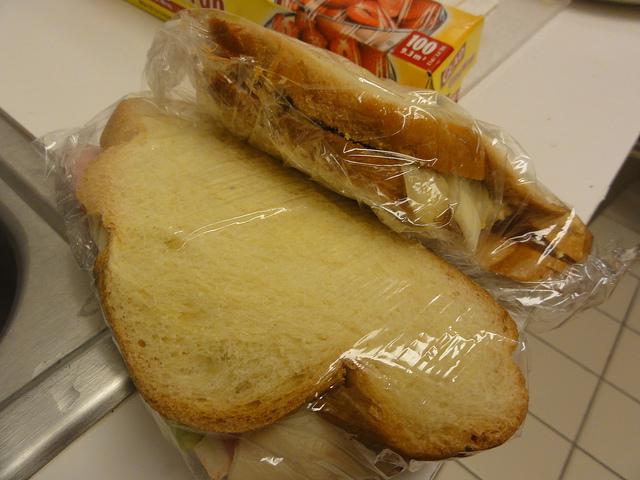What are the sandwiches sitting by?
Write a very short answer. Sink. Was the lunch packed a home?
Short answer required. Yes. What is wrapped around the sandwiches?
Write a very short answer. Plastic wrap. 